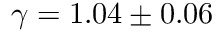Convert formula to latex. <formula><loc_0><loc_0><loc_500><loc_500>\gamma = 1 . 0 4 \pm 0 . 0 6</formula> 